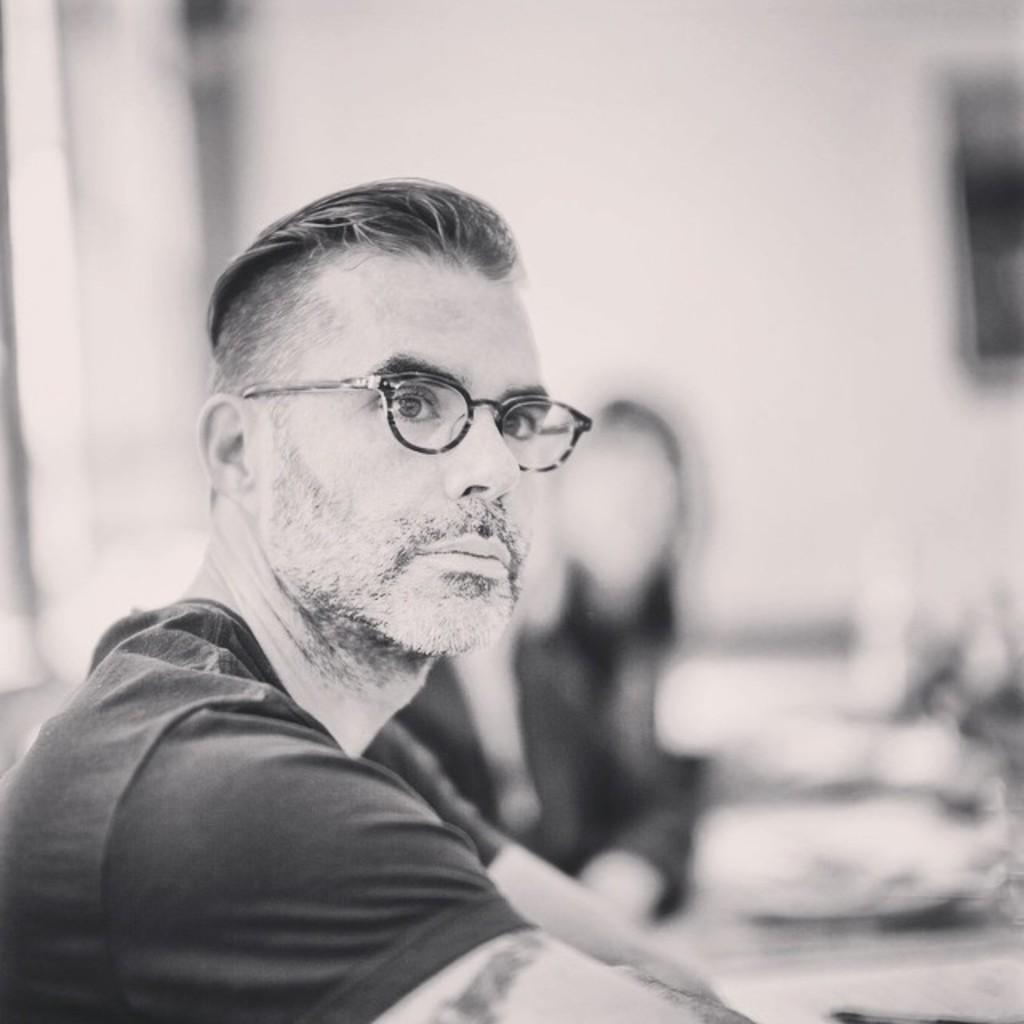What is the color scheme of the image? The image is black and white. What are the people in the image doing? The people in the image are sitting. Can you describe any specific features of one of the people? One person is wearing spectacles. What can be observed about the background of the image? The background is blurred. What type of tin can be seen in the image? There is no tin present in the image. Does the existence of the people in the image prove the existence of extraterrestrial life? The presence of people in the image does not prove the existence of extraterrestrial life, as the image only depicts human beings. 